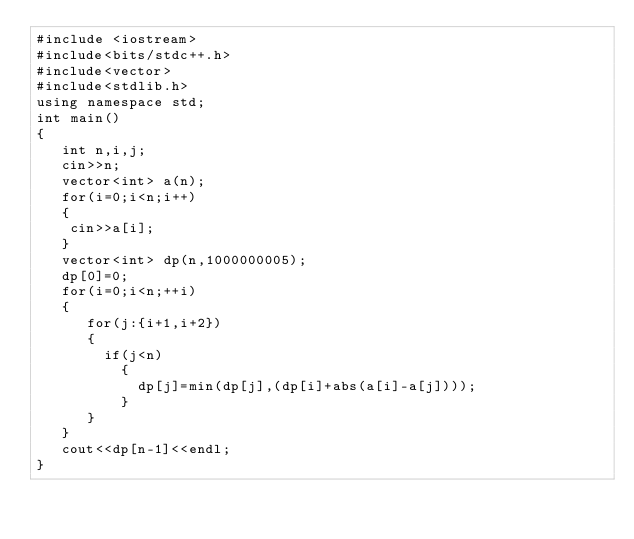<code> <loc_0><loc_0><loc_500><loc_500><_C++_>#include <iostream>
#include<bits/stdc++.h>
#include<vector>
#include<stdlib.h>
using namespace std;
int main()
{
   int n,i,j;
   cin>>n;
   vector<int> a(n);
   for(i=0;i<n;i++)
   {
   	cin>>a[i];
   }
   vector<int> dp(n,1000000005);
   dp[0]=0;
   for(i=0;i<n;++i)
   {
   	  for(j:{i+1,i+2})
   	  {
   	  	if(j<n)
   	      {
   	  	    dp[j]=min(dp[j],(dp[i]+abs(a[i]-a[j])));
   	      }
   	  }
   }
   cout<<dp[n-1]<<endl;
}
</code> 